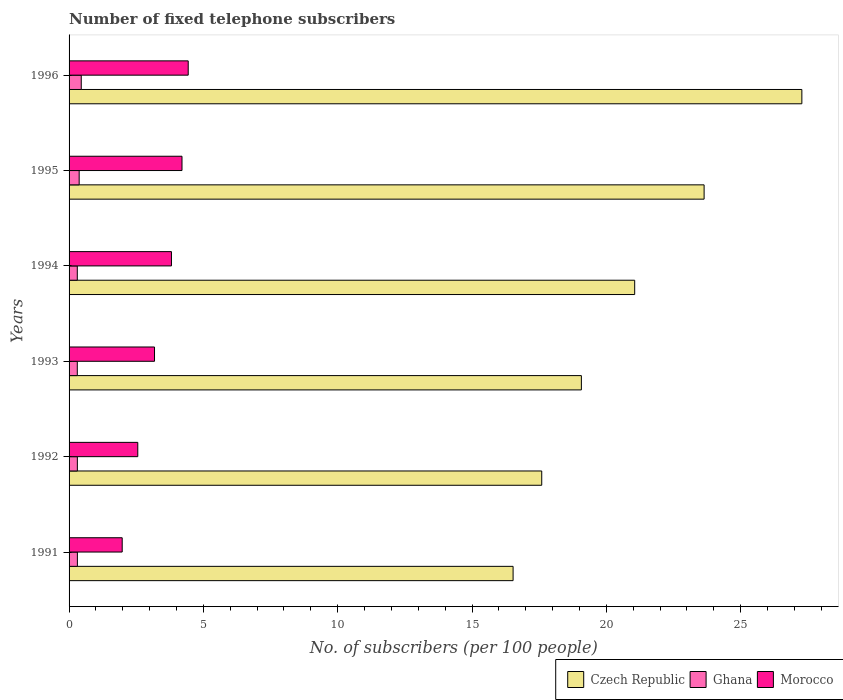How many bars are there on the 6th tick from the top?
Your answer should be compact. 3. What is the label of the 5th group of bars from the top?
Provide a succinct answer. 1992. In how many cases, is the number of bars for a given year not equal to the number of legend labels?
Keep it short and to the point. 0. What is the number of fixed telephone subscribers in Morocco in 1992?
Provide a succinct answer. 2.56. Across all years, what is the maximum number of fixed telephone subscribers in Czech Republic?
Your answer should be compact. 27.28. Across all years, what is the minimum number of fixed telephone subscribers in Czech Republic?
Offer a very short reply. 16.53. What is the total number of fixed telephone subscribers in Ghana in the graph?
Keep it short and to the point. 2.06. What is the difference between the number of fixed telephone subscribers in Morocco in 1992 and that in 1993?
Provide a short and direct response. -0.62. What is the difference between the number of fixed telephone subscribers in Morocco in 1993 and the number of fixed telephone subscribers in Czech Republic in 1996?
Ensure brevity in your answer.  -24.1. What is the average number of fixed telephone subscribers in Ghana per year?
Provide a succinct answer. 0.34. In the year 1992, what is the difference between the number of fixed telephone subscribers in Morocco and number of fixed telephone subscribers in Czech Republic?
Offer a terse response. -15.04. In how many years, is the number of fixed telephone subscribers in Morocco greater than 26 ?
Offer a very short reply. 0. What is the ratio of the number of fixed telephone subscribers in Morocco in 1991 to that in 1995?
Give a very brief answer. 0.47. Is the difference between the number of fixed telephone subscribers in Morocco in 1992 and 1996 greater than the difference between the number of fixed telephone subscribers in Czech Republic in 1992 and 1996?
Offer a terse response. Yes. What is the difference between the highest and the second highest number of fixed telephone subscribers in Czech Republic?
Your response must be concise. 3.64. What is the difference between the highest and the lowest number of fixed telephone subscribers in Czech Republic?
Your answer should be compact. 10.75. In how many years, is the number of fixed telephone subscribers in Ghana greater than the average number of fixed telephone subscribers in Ghana taken over all years?
Keep it short and to the point. 2. Is the sum of the number of fixed telephone subscribers in Ghana in 1993 and 1994 greater than the maximum number of fixed telephone subscribers in Czech Republic across all years?
Give a very brief answer. No. What does the 3rd bar from the top in 1994 represents?
Offer a terse response. Czech Republic. What does the 2nd bar from the bottom in 1995 represents?
Keep it short and to the point. Ghana. What is the difference between two consecutive major ticks on the X-axis?
Ensure brevity in your answer.  5. How many legend labels are there?
Provide a succinct answer. 3. What is the title of the graph?
Provide a short and direct response. Number of fixed telephone subscribers. What is the label or title of the X-axis?
Keep it short and to the point. No. of subscribers (per 100 people). What is the label or title of the Y-axis?
Ensure brevity in your answer.  Years. What is the No. of subscribers (per 100 people) in Czech Republic in 1991?
Give a very brief answer. 16.53. What is the No. of subscribers (per 100 people) in Ghana in 1991?
Offer a terse response. 0.31. What is the No. of subscribers (per 100 people) in Morocco in 1991?
Ensure brevity in your answer.  1.98. What is the No. of subscribers (per 100 people) in Czech Republic in 1992?
Offer a very short reply. 17.59. What is the No. of subscribers (per 100 people) of Ghana in 1992?
Provide a succinct answer. 0.31. What is the No. of subscribers (per 100 people) of Morocco in 1992?
Give a very brief answer. 2.56. What is the No. of subscribers (per 100 people) in Czech Republic in 1993?
Make the answer very short. 19.07. What is the No. of subscribers (per 100 people) in Ghana in 1993?
Give a very brief answer. 0.31. What is the No. of subscribers (per 100 people) in Morocco in 1993?
Your answer should be very brief. 3.18. What is the No. of subscribers (per 100 people) in Czech Republic in 1994?
Provide a succinct answer. 21.06. What is the No. of subscribers (per 100 people) of Ghana in 1994?
Provide a short and direct response. 0.31. What is the No. of subscribers (per 100 people) of Morocco in 1994?
Provide a short and direct response. 3.81. What is the No. of subscribers (per 100 people) of Czech Republic in 1995?
Provide a short and direct response. 23.64. What is the No. of subscribers (per 100 people) in Ghana in 1995?
Provide a short and direct response. 0.38. What is the No. of subscribers (per 100 people) in Morocco in 1995?
Provide a succinct answer. 4.2. What is the No. of subscribers (per 100 people) of Czech Republic in 1996?
Provide a succinct answer. 27.28. What is the No. of subscribers (per 100 people) in Ghana in 1996?
Your answer should be very brief. 0.45. What is the No. of subscribers (per 100 people) in Morocco in 1996?
Your response must be concise. 4.44. Across all years, what is the maximum No. of subscribers (per 100 people) of Czech Republic?
Make the answer very short. 27.28. Across all years, what is the maximum No. of subscribers (per 100 people) of Ghana?
Your answer should be compact. 0.45. Across all years, what is the maximum No. of subscribers (per 100 people) of Morocco?
Keep it short and to the point. 4.44. Across all years, what is the minimum No. of subscribers (per 100 people) in Czech Republic?
Give a very brief answer. 16.53. Across all years, what is the minimum No. of subscribers (per 100 people) of Ghana?
Ensure brevity in your answer.  0.31. Across all years, what is the minimum No. of subscribers (per 100 people) of Morocco?
Your answer should be compact. 1.98. What is the total No. of subscribers (per 100 people) of Czech Republic in the graph?
Offer a terse response. 125.17. What is the total No. of subscribers (per 100 people) of Ghana in the graph?
Give a very brief answer. 2.06. What is the total No. of subscribers (per 100 people) in Morocco in the graph?
Your answer should be very brief. 20.17. What is the difference between the No. of subscribers (per 100 people) in Czech Republic in 1991 and that in 1992?
Provide a succinct answer. -1.07. What is the difference between the No. of subscribers (per 100 people) of Ghana in 1991 and that in 1992?
Your answer should be very brief. 0. What is the difference between the No. of subscribers (per 100 people) in Morocco in 1991 and that in 1992?
Your answer should be compact. -0.58. What is the difference between the No. of subscribers (per 100 people) of Czech Republic in 1991 and that in 1993?
Make the answer very short. -2.54. What is the difference between the No. of subscribers (per 100 people) in Ghana in 1991 and that in 1993?
Your response must be concise. 0. What is the difference between the No. of subscribers (per 100 people) in Morocco in 1991 and that in 1993?
Your answer should be very brief. -1.2. What is the difference between the No. of subscribers (per 100 people) of Czech Republic in 1991 and that in 1994?
Make the answer very short. -4.53. What is the difference between the No. of subscribers (per 100 people) in Ghana in 1991 and that in 1994?
Offer a very short reply. 0. What is the difference between the No. of subscribers (per 100 people) in Morocco in 1991 and that in 1994?
Provide a short and direct response. -1.83. What is the difference between the No. of subscribers (per 100 people) in Czech Republic in 1991 and that in 1995?
Provide a succinct answer. -7.11. What is the difference between the No. of subscribers (per 100 people) of Ghana in 1991 and that in 1995?
Give a very brief answer. -0.07. What is the difference between the No. of subscribers (per 100 people) of Morocco in 1991 and that in 1995?
Keep it short and to the point. -2.23. What is the difference between the No. of subscribers (per 100 people) in Czech Republic in 1991 and that in 1996?
Provide a succinct answer. -10.75. What is the difference between the No. of subscribers (per 100 people) of Ghana in 1991 and that in 1996?
Give a very brief answer. -0.14. What is the difference between the No. of subscribers (per 100 people) in Morocco in 1991 and that in 1996?
Your answer should be compact. -2.46. What is the difference between the No. of subscribers (per 100 people) of Czech Republic in 1992 and that in 1993?
Give a very brief answer. -1.48. What is the difference between the No. of subscribers (per 100 people) of Ghana in 1992 and that in 1993?
Ensure brevity in your answer.  0. What is the difference between the No. of subscribers (per 100 people) in Morocco in 1992 and that in 1993?
Provide a succinct answer. -0.62. What is the difference between the No. of subscribers (per 100 people) of Czech Republic in 1992 and that in 1994?
Offer a terse response. -3.46. What is the difference between the No. of subscribers (per 100 people) in Ghana in 1992 and that in 1994?
Offer a terse response. 0. What is the difference between the No. of subscribers (per 100 people) in Morocco in 1992 and that in 1994?
Offer a terse response. -1.25. What is the difference between the No. of subscribers (per 100 people) of Czech Republic in 1992 and that in 1995?
Your answer should be compact. -6.04. What is the difference between the No. of subscribers (per 100 people) in Ghana in 1992 and that in 1995?
Your answer should be very brief. -0.07. What is the difference between the No. of subscribers (per 100 people) of Morocco in 1992 and that in 1995?
Your answer should be very brief. -1.65. What is the difference between the No. of subscribers (per 100 people) in Czech Republic in 1992 and that in 1996?
Your answer should be very brief. -9.68. What is the difference between the No. of subscribers (per 100 people) of Ghana in 1992 and that in 1996?
Your answer should be compact. -0.14. What is the difference between the No. of subscribers (per 100 people) in Morocco in 1992 and that in 1996?
Provide a succinct answer. -1.88. What is the difference between the No. of subscribers (per 100 people) in Czech Republic in 1993 and that in 1994?
Your response must be concise. -1.98. What is the difference between the No. of subscribers (per 100 people) of Morocco in 1993 and that in 1994?
Provide a short and direct response. -0.63. What is the difference between the No. of subscribers (per 100 people) of Czech Republic in 1993 and that in 1995?
Your answer should be very brief. -4.57. What is the difference between the No. of subscribers (per 100 people) in Ghana in 1993 and that in 1995?
Provide a succinct answer. -0.07. What is the difference between the No. of subscribers (per 100 people) of Morocco in 1993 and that in 1995?
Provide a succinct answer. -1.02. What is the difference between the No. of subscribers (per 100 people) in Czech Republic in 1993 and that in 1996?
Give a very brief answer. -8.21. What is the difference between the No. of subscribers (per 100 people) in Ghana in 1993 and that in 1996?
Make the answer very short. -0.15. What is the difference between the No. of subscribers (per 100 people) in Morocco in 1993 and that in 1996?
Offer a very short reply. -1.25. What is the difference between the No. of subscribers (per 100 people) in Czech Republic in 1994 and that in 1995?
Provide a succinct answer. -2.58. What is the difference between the No. of subscribers (per 100 people) of Ghana in 1994 and that in 1995?
Your answer should be compact. -0.07. What is the difference between the No. of subscribers (per 100 people) of Morocco in 1994 and that in 1995?
Provide a short and direct response. -0.39. What is the difference between the No. of subscribers (per 100 people) of Czech Republic in 1994 and that in 1996?
Your response must be concise. -6.22. What is the difference between the No. of subscribers (per 100 people) in Ghana in 1994 and that in 1996?
Offer a very short reply. -0.15. What is the difference between the No. of subscribers (per 100 people) in Morocco in 1994 and that in 1996?
Make the answer very short. -0.62. What is the difference between the No. of subscribers (per 100 people) of Czech Republic in 1995 and that in 1996?
Provide a succinct answer. -3.64. What is the difference between the No. of subscribers (per 100 people) in Ghana in 1995 and that in 1996?
Offer a terse response. -0.08. What is the difference between the No. of subscribers (per 100 people) of Morocco in 1995 and that in 1996?
Provide a succinct answer. -0.23. What is the difference between the No. of subscribers (per 100 people) in Czech Republic in 1991 and the No. of subscribers (per 100 people) in Ghana in 1992?
Offer a very short reply. 16.22. What is the difference between the No. of subscribers (per 100 people) in Czech Republic in 1991 and the No. of subscribers (per 100 people) in Morocco in 1992?
Offer a very short reply. 13.97. What is the difference between the No. of subscribers (per 100 people) of Ghana in 1991 and the No. of subscribers (per 100 people) of Morocco in 1992?
Keep it short and to the point. -2.25. What is the difference between the No. of subscribers (per 100 people) in Czech Republic in 1991 and the No. of subscribers (per 100 people) in Ghana in 1993?
Offer a terse response. 16.22. What is the difference between the No. of subscribers (per 100 people) of Czech Republic in 1991 and the No. of subscribers (per 100 people) of Morocco in 1993?
Your answer should be very brief. 13.35. What is the difference between the No. of subscribers (per 100 people) in Ghana in 1991 and the No. of subscribers (per 100 people) in Morocco in 1993?
Provide a short and direct response. -2.87. What is the difference between the No. of subscribers (per 100 people) of Czech Republic in 1991 and the No. of subscribers (per 100 people) of Ghana in 1994?
Your answer should be compact. 16.22. What is the difference between the No. of subscribers (per 100 people) in Czech Republic in 1991 and the No. of subscribers (per 100 people) in Morocco in 1994?
Offer a terse response. 12.72. What is the difference between the No. of subscribers (per 100 people) in Ghana in 1991 and the No. of subscribers (per 100 people) in Morocco in 1994?
Make the answer very short. -3.5. What is the difference between the No. of subscribers (per 100 people) in Czech Republic in 1991 and the No. of subscribers (per 100 people) in Ghana in 1995?
Your response must be concise. 16.15. What is the difference between the No. of subscribers (per 100 people) in Czech Republic in 1991 and the No. of subscribers (per 100 people) in Morocco in 1995?
Make the answer very short. 12.32. What is the difference between the No. of subscribers (per 100 people) of Ghana in 1991 and the No. of subscribers (per 100 people) of Morocco in 1995?
Offer a terse response. -3.89. What is the difference between the No. of subscribers (per 100 people) of Czech Republic in 1991 and the No. of subscribers (per 100 people) of Ghana in 1996?
Your answer should be compact. 16.07. What is the difference between the No. of subscribers (per 100 people) in Czech Republic in 1991 and the No. of subscribers (per 100 people) in Morocco in 1996?
Offer a terse response. 12.09. What is the difference between the No. of subscribers (per 100 people) of Ghana in 1991 and the No. of subscribers (per 100 people) of Morocco in 1996?
Your answer should be very brief. -4.13. What is the difference between the No. of subscribers (per 100 people) in Czech Republic in 1992 and the No. of subscribers (per 100 people) in Ghana in 1993?
Keep it short and to the point. 17.29. What is the difference between the No. of subscribers (per 100 people) in Czech Republic in 1992 and the No. of subscribers (per 100 people) in Morocco in 1993?
Your answer should be very brief. 14.41. What is the difference between the No. of subscribers (per 100 people) in Ghana in 1992 and the No. of subscribers (per 100 people) in Morocco in 1993?
Your answer should be very brief. -2.87. What is the difference between the No. of subscribers (per 100 people) of Czech Republic in 1992 and the No. of subscribers (per 100 people) of Ghana in 1994?
Your answer should be compact. 17.29. What is the difference between the No. of subscribers (per 100 people) of Czech Republic in 1992 and the No. of subscribers (per 100 people) of Morocco in 1994?
Keep it short and to the point. 13.78. What is the difference between the No. of subscribers (per 100 people) of Ghana in 1992 and the No. of subscribers (per 100 people) of Morocco in 1994?
Your answer should be very brief. -3.5. What is the difference between the No. of subscribers (per 100 people) of Czech Republic in 1992 and the No. of subscribers (per 100 people) of Ghana in 1995?
Your answer should be compact. 17.22. What is the difference between the No. of subscribers (per 100 people) of Czech Republic in 1992 and the No. of subscribers (per 100 people) of Morocco in 1995?
Make the answer very short. 13.39. What is the difference between the No. of subscribers (per 100 people) of Ghana in 1992 and the No. of subscribers (per 100 people) of Morocco in 1995?
Ensure brevity in your answer.  -3.9. What is the difference between the No. of subscribers (per 100 people) of Czech Republic in 1992 and the No. of subscribers (per 100 people) of Ghana in 1996?
Keep it short and to the point. 17.14. What is the difference between the No. of subscribers (per 100 people) in Czech Republic in 1992 and the No. of subscribers (per 100 people) in Morocco in 1996?
Ensure brevity in your answer.  13.16. What is the difference between the No. of subscribers (per 100 people) of Ghana in 1992 and the No. of subscribers (per 100 people) of Morocco in 1996?
Make the answer very short. -4.13. What is the difference between the No. of subscribers (per 100 people) of Czech Republic in 1993 and the No. of subscribers (per 100 people) of Ghana in 1994?
Your answer should be very brief. 18.76. What is the difference between the No. of subscribers (per 100 people) in Czech Republic in 1993 and the No. of subscribers (per 100 people) in Morocco in 1994?
Ensure brevity in your answer.  15.26. What is the difference between the No. of subscribers (per 100 people) of Ghana in 1993 and the No. of subscribers (per 100 people) of Morocco in 1994?
Your answer should be compact. -3.51. What is the difference between the No. of subscribers (per 100 people) of Czech Republic in 1993 and the No. of subscribers (per 100 people) of Ghana in 1995?
Make the answer very short. 18.69. What is the difference between the No. of subscribers (per 100 people) of Czech Republic in 1993 and the No. of subscribers (per 100 people) of Morocco in 1995?
Ensure brevity in your answer.  14.87. What is the difference between the No. of subscribers (per 100 people) of Ghana in 1993 and the No. of subscribers (per 100 people) of Morocco in 1995?
Your answer should be very brief. -3.9. What is the difference between the No. of subscribers (per 100 people) in Czech Republic in 1993 and the No. of subscribers (per 100 people) in Ghana in 1996?
Provide a succinct answer. 18.62. What is the difference between the No. of subscribers (per 100 people) of Czech Republic in 1993 and the No. of subscribers (per 100 people) of Morocco in 1996?
Your response must be concise. 14.64. What is the difference between the No. of subscribers (per 100 people) in Ghana in 1993 and the No. of subscribers (per 100 people) in Morocco in 1996?
Your answer should be very brief. -4.13. What is the difference between the No. of subscribers (per 100 people) of Czech Republic in 1994 and the No. of subscribers (per 100 people) of Ghana in 1995?
Your answer should be very brief. 20.68. What is the difference between the No. of subscribers (per 100 people) in Czech Republic in 1994 and the No. of subscribers (per 100 people) in Morocco in 1995?
Give a very brief answer. 16.85. What is the difference between the No. of subscribers (per 100 people) of Ghana in 1994 and the No. of subscribers (per 100 people) of Morocco in 1995?
Provide a succinct answer. -3.9. What is the difference between the No. of subscribers (per 100 people) of Czech Republic in 1994 and the No. of subscribers (per 100 people) of Ghana in 1996?
Provide a short and direct response. 20.6. What is the difference between the No. of subscribers (per 100 people) in Czech Republic in 1994 and the No. of subscribers (per 100 people) in Morocco in 1996?
Your answer should be compact. 16.62. What is the difference between the No. of subscribers (per 100 people) in Ghana in 1994 and the No. of subscribers (per 100 people) in Morocco in 1996?
Offer a very short reply. -4.13. What is the difference between the No. of subscribers (per 100 people) of Czech Republic in 1995 and the No. of subscribers (per 100 people) of Ghana in 1996?
Offer a very short reply. 23.19. What is the difference between the No. of subscribers (per 100 people) in Czech Republic in 1995 and the No. of subscribers (per 100 people) in Morocco in 1996?
Keep it short and to the point. 19.2. What is the difference between the No. of subscribers (per 100 people) of Ghana in 1995 and the No. of subscribers (per 100 people) of Morocco in 1996?
Provide a short and direct response. -4.06. What is the average No. of subscribers (per 100 people) in Czech Republic per year?
Offer a terse response. 20.86. What is the average No. of subscribers (per 100 people) in Ghana per year?
Provide a short and direct response. 0.34. What is the average No. of subscribers (per 100 people) of Morocco per year?
Provide a succinct answer. 3.36. In the year 1991, what is the difference between the No. of subscribers (per 100 people) of Czech Republic and No. of subscribers (per 100 people) of Ghana?
Offer a very short reply. 16.22. In the year 1991, what is the difference between the No. of subscribers (per 100 people) in Czech Republic and No. of subscribers (per 100 people) in Morocco?
Offer a terse response. 14.55. In the year 1991, what is the difference between the No. of subscribers (per 100 people) in Ghana and No. of subscribers (per 100 people) in Morocco?
Your answer should be very brief. -1.67. In the year 1992, what is the difference between the No. of subscribers (per 100 people) in Czech Republic and No. of subscribers (per 100 people) in Ghana?
Offer a very short reply. 17.29. In the year 1992, what is the difference between the No. of subscribers (per 100 people) in Czech Republic and No. of subscribers (per 100 people) in Morocco?
Your answer should be compact. 15.04. In the year 1992, what is the difference between the No. of subscribers (per 100 people) in Ghana and No. of subscribers (per 100 people) in Morocco?
Provide a succinct answer. -2.25. In the year 1993, what is the difference between the No. of subscribers (per 100 people) of Czech Republic and No. of subscribers (per 100 people) of Ghana?
Your response must be concise. 18.76. In the year 1993, what is the difference between the No. of subscribers (per 100 people) of Czech Republic and No. of subscribers (per 100 people) of Morocco?
Offer a terse response. 15.89. In the year 1993, what is the difference between the No. of subscribers (per 100 people) of Ghana and No. of subscribers (per 100 people) of Morocco?
Offer a terse response. -2.87. In the year 1994, what is the difference between the No. of subscribers (per 100 people) in Czech Republic and No. of subscribers (per 100 people) in Ghana?
Ensure brevity in your answer.  20.75. In the year 1994, what is the difference between the No. of subscribers (per 100 people) of Czech Republic and No. of subscribers (per 100 people) of Morocco?
Give a very brief answer. 17.24. In the year 1994, what is the difference between the No. of subscribers (per 100 people) of Ghana and No. of subscribers (per 100 people) of Morocco?
Provide a short and direct response. -3.51. In the year 1995, what is the difference between the No. of subscribers (per 100 people) of Czech Republic and No. of subscribers (per 100 people) of Ghana?
Make the answer very short. 23.26. In the year 1995, what is the difference between the No. of subscribers (per 100 people) in Czech Republic and No. of subscribers (per 100 people) in Morocco?
Give a very brief answer. 19.44. In the year 1995, what is the difference between the No. of subscribers (per 100 people) in Ghana and No. of subscribers (per 100 people) in Morocco?
Your response must be concise. -3.83. In the year 1996, what is the difference between the No. of subscribers (per 100 people) of Czech Republic and No. of subscribers (per 100 people) of Ghana?
Offer a terse response. 26.82. In the year 1996, what is the difference between the No. of subscribers (per 100 people) in Czech Republic and No. of subscribers (per 100 people) in Morocco?
Ensure brevity in your answer.  22.84. In the year 1996, what is the difference between the No. of subscribers (per 100 people) of Ghana and No. of subscribers (per 100 people) of Morocco?
Ensure brevity in your answer.  -3.98. What is the ratio of the No. of subscribers (per 100 people) in Czech Republic in 1991 to that in 1992?
Your answer should be very brief. 0.94. What is the ratio of the No. of subscribers (per 100 people) in Ghana in 1991 to that in 1992?
Offer a very short reply. 1. What is the ratio of the No. of subscribers (per 100 people) of Morocco in 1991 to that in 1992?
Provide a short and direct response. 0.77. What is the ratio of the No. of subscribers (per 100 people) in Czech Republic in 1991 to that in 1993?
Ensure brevity in your answer.  0.87. What is the ratio of the No. of subscribers (per 100 people) of Ghana in 1991 to that in 1993?
Ensure brevity in your answer.  1.01. What is the ratio of the No. of subscribers (per 100 people) in Morocco in 1991 to that in 1993?
Provide a short and direct response. 0.62. What is the ratio of the No. of subscribers (per 100 people) in Czech Republic in 1991 to that in 1994?
Your answer should be compact. 0.79. What is the ratio of the No. of subscribers (per 100 people) in Ghana in 1991 to that in 1994?
Provide a succinct answer. 1.01. What is the ratio of the No. of subscribers (per 100 people) in Morocco in 1991 to that in 1994?
Give a very brief answer. 0.52. What is the ratio of the No. of subscribers (per 100 people) in Czech Republic in 1991 to that in 1995?
Ensure brevity in your answer.  0.7. What is the ratio of the No. of subscribers (per 100 people) in Ghana in 1991 to that in 1995?
Give a very brief answer. 0.82. What is the ratio of the No. of subscribers (per 100 people) of Morocco in 1991 to that in 1995?
Ensure brevity in your answer.  0.47. What is the ratio of the No. of subscribers (per 100 people) in Czech Republic in 1991 to that in 1996?
Offer a terse response. 0.61. What is the ratio of the No. of subscribers (per 100 people) of Ghana in 1991 to that in 1996?
Your response must be concise. 0.68. What is the ratio of the No. of subscribers (per 100 people) in Morocco in 1991 to that in 1996?
Ensure brevity in your answer.  0.45. What is the ratio of the No. of subscribers (per 100 people) of Czech Republic in 1992 to that in 1993?
Your answer should be compact. 0.92. What is the ratio of the No. of subscribers (per 100 people) of Ghana in 1992 to that in 1993?
Your answer should be compact. 1.01. What is the ratio of the No. of subscribers (per 100 people) in Morocco in 1992 to that in 1993?
Provide a succinct answer. 0.8. What is the ratio of the No. of subscribers (per 100 people) of Czech Republic in 1992 to that in 1994?
Provide a short and direct response. 0.84. What is the ratio of the No. of subscribers (per 100 people) in Ghana in 1992 to that in 1994?
Make the answer very short. 1.01. What is the ratio of the No. of subscribers (per 100 people) in Morocco in 1992 to that in 1994?
Your response must be concise. 0.67. What is the ratio of the No. of subscribers (per 100 people) of Czech Republic in 1992 to that in 1995?
Your response must be concise. 0.74. What is the ratio of the No. of subscribers (per 100 people) of Ghana in 1992 to that in 1995?
Provide a succinct answer. 0.82. What is the ratio of the No. of subscribers (per 100 people) of Morocco in 1992 to that in 1995?
Make the answer very short. 0.61. What is the ratio of the No. of subscribers (per 100 people) in Czech Republic in 1992 to that in 1996?
Provide a succinct answer. 0.65. What is the ratio of the No. of subscribers (per 100 people) in Ghana in 1992 to that in 1996?
Offer a terse response. 0.68. What is the ratio of the No. of subscribers (per 100 people) in Morocco in 1992 to that in 1996?
Ensure brevity in your answer.  0.58. What is the ratio of the No. of subscribers (per 100 people) in Czech Republic in 1993 to that in 1994?
Your response must be concise. 0.91. What is the ratio of the No. of subscribers (per 100 people) of Morocco in 1993 to that in 1994?
Make the answer very short. 0.83. What is the ratio of the No. of subscribers (per 100 people) in Czech Republic in 1993 to that in 1995?
Provide a short and direct response. 0.81. What is the ratio of the No. of subscribers (per 100 people) of Ghana in 1993 to that in 1995?
Give a very brief answer. 0.81. What is the ratio of the No. of subscribers (per 100 people) in Morocco in 1993 to that in 1995?
Provide a succinct answer. 0.76. What is the ratio of the No. of subscribers (per 100 people) in Czech Republic in 1993 to that in 1996?
Give a very brief answer. 0.7. What is the ratio of the No. of subscribers (per 100 people) of Ghana in 1993 to that in 1996?
Keep it short and to the point. 0.67. What is the ratio of the No. of subscribers (per 100 people) in Morocco in 1993 to that in 1996?
Keep it short and to the point. 0.72. What is the ratio of the No. of subscribers (per 100 people) in Czech Republic in 1994 to that in 1995?
Your answer should be compact. 0.89. What is the ratio of the No. of subscribers (per 100 people) in Ghana in 1994 to that in 1995?
Make the answer very short. 0.81. What is the ratio of the No. of subscribers (per 100 people) of Morocco in 1994 to that in 1995?
Your answer should be very brief. 0.91. What is the ratio of the No. of subscribers (per 100 people) of Czech Republic in 1994 to that in 1996?
Ensure brevity in your answer.  0.77. What is the ratio of the No. of subscribers (per 100 people) in Ghana in 1994 to that in 1996?
Offer a very short reply. 0.67. What is the ratio of the No. of subscribers (per 100 people) in Morocco in 1994 to that in 1996?
Offer a terse response. 0.86. What is the ratio of the No. of subscribers (per 100 people) of Czech Republic in 1995 to that in 1996?
Provide a succinct answer. 0.87. What is the ratio of the No. of subscribers (per 100 people) of Ghana in 1995 to that in 1996?
Offer a terse response. 0.83. What is the ratio of the No. of subscribers (per 100 people) in Morocco in 1995 to that in 1996?
Your response must be concise. 0.95. What is the difference between the highest and the second highest No. of subscribers (per 100 people) in Czech Republic?
Your answer should be very brief. 3.64. What is the difference between the highest and the second highest No. of subscribers (per 100 people) in Ghana?
Your answer should be compact. 0.08. What is the difference between the highest and the second highest No. of subscribers (per 100 people) in Morocco?
Ensure brevity in your answer.  0.23. What is the difference between the highest and the lowest No. of subscribers (per 100 people) of Czech Republic?
Offer a very short reply. 10.75. What is the difference between the highest and the lowest No. of subscribers (per 100 people) of Ghana?
Provide a short and direct response. 0.15. What is the difference between the highest and the lowest No. of subscribers (per 100 people) in Morocco?
Your answer should be very brief. 2.46. 